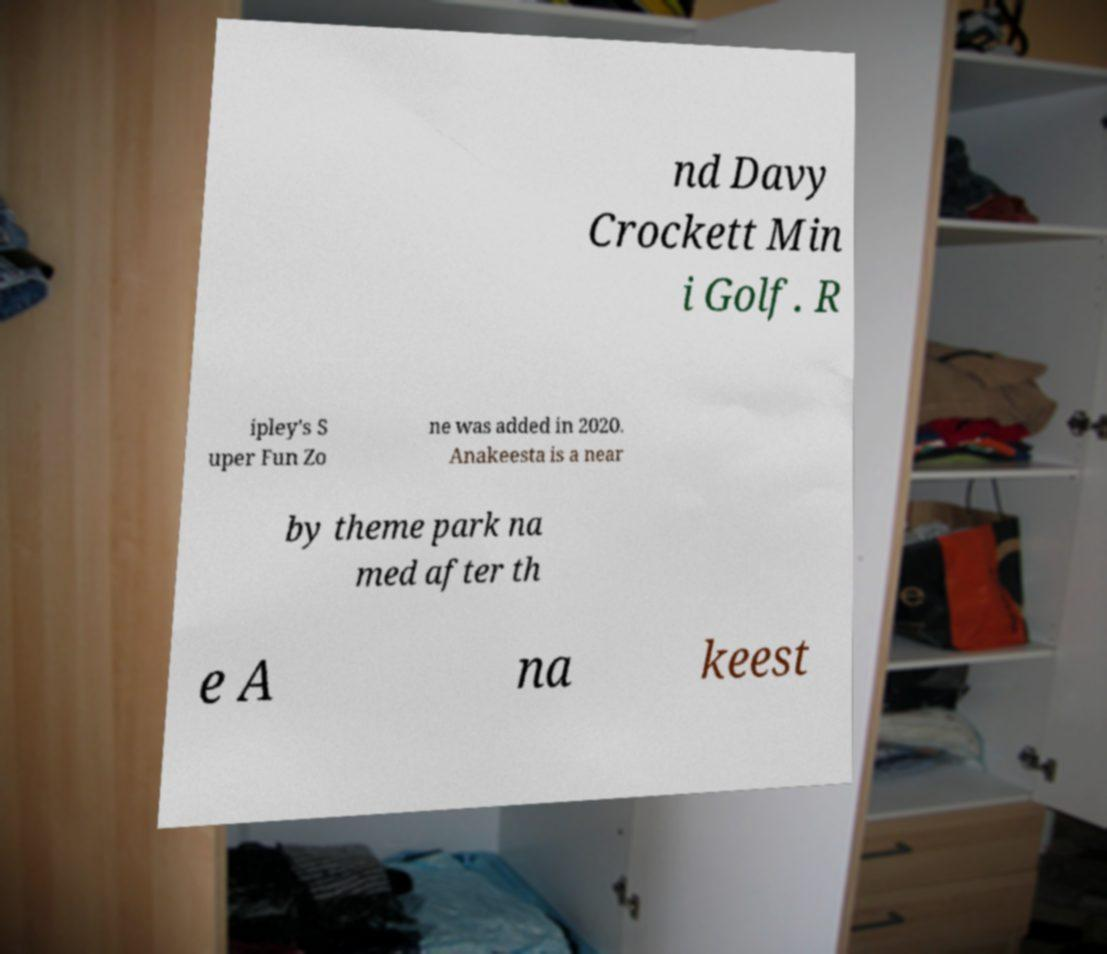Could you assist in decoding the text presented in this image and type it out clearly? nd Davy Crockett Min i Golf. R ipley's S uper Fun Zo ne was added in 2020. Anakeesta is a near by theme park na med after th e A na keest 